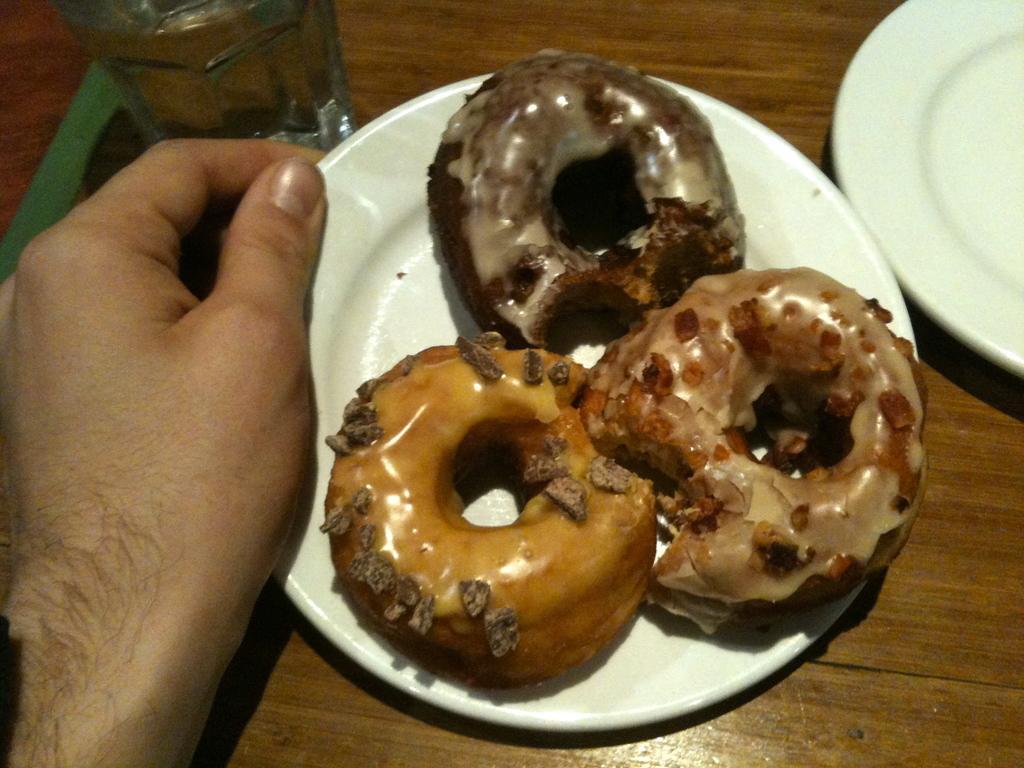How would you summarize this image in a sentence or two? In this image we can see three donuts on a plate carried by a person, there is another plate and glass which are placed on a table. 